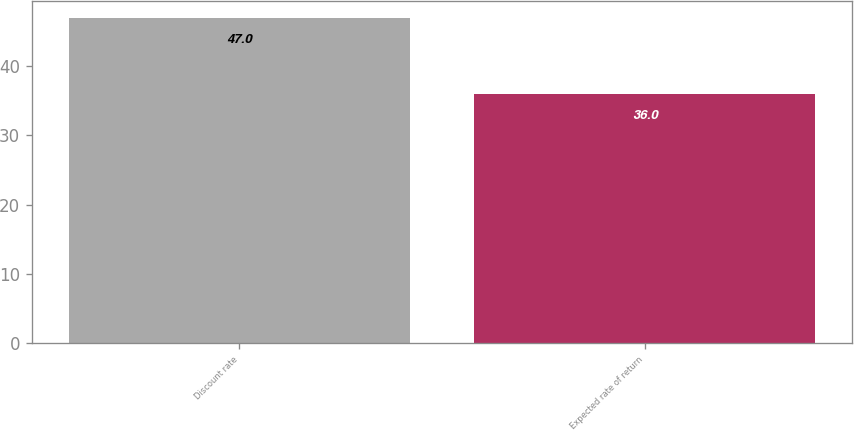<chart> <loc_0><loc_0><loc_500><loc_500><bar_chart><fcel>Discount rate<fcel>Expected rate of return<nl><fcel>47<fcel>36<nl></chart> 